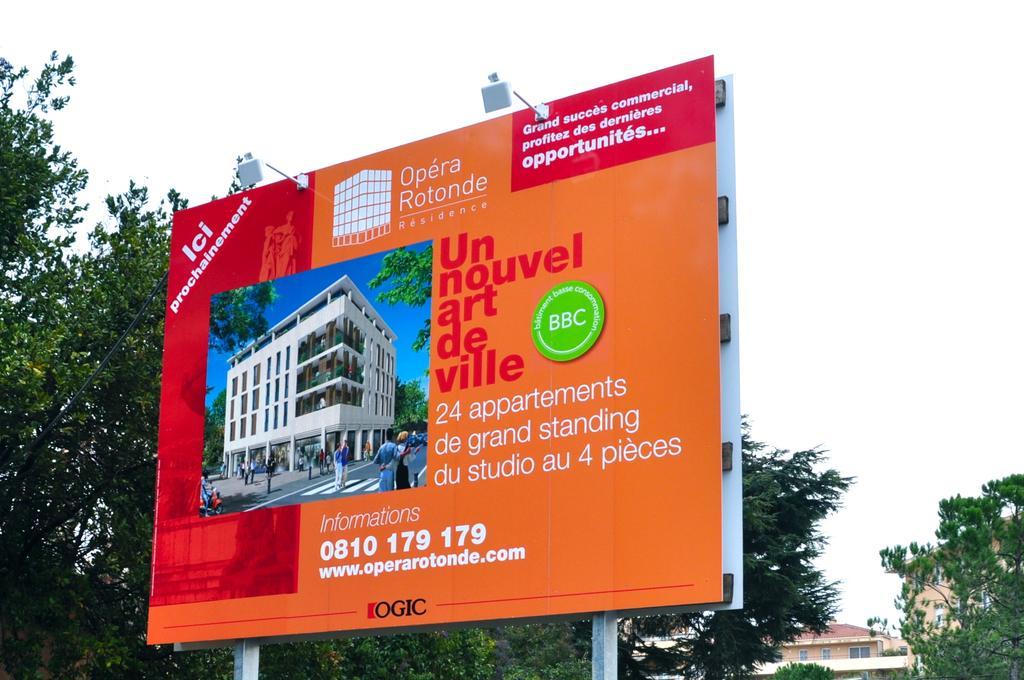In one or two sentences, can you explain what this image depicts? In this picture we can see the poles with hoardings and lights. Behind the hoardings there are trees, buildings and the sky. 